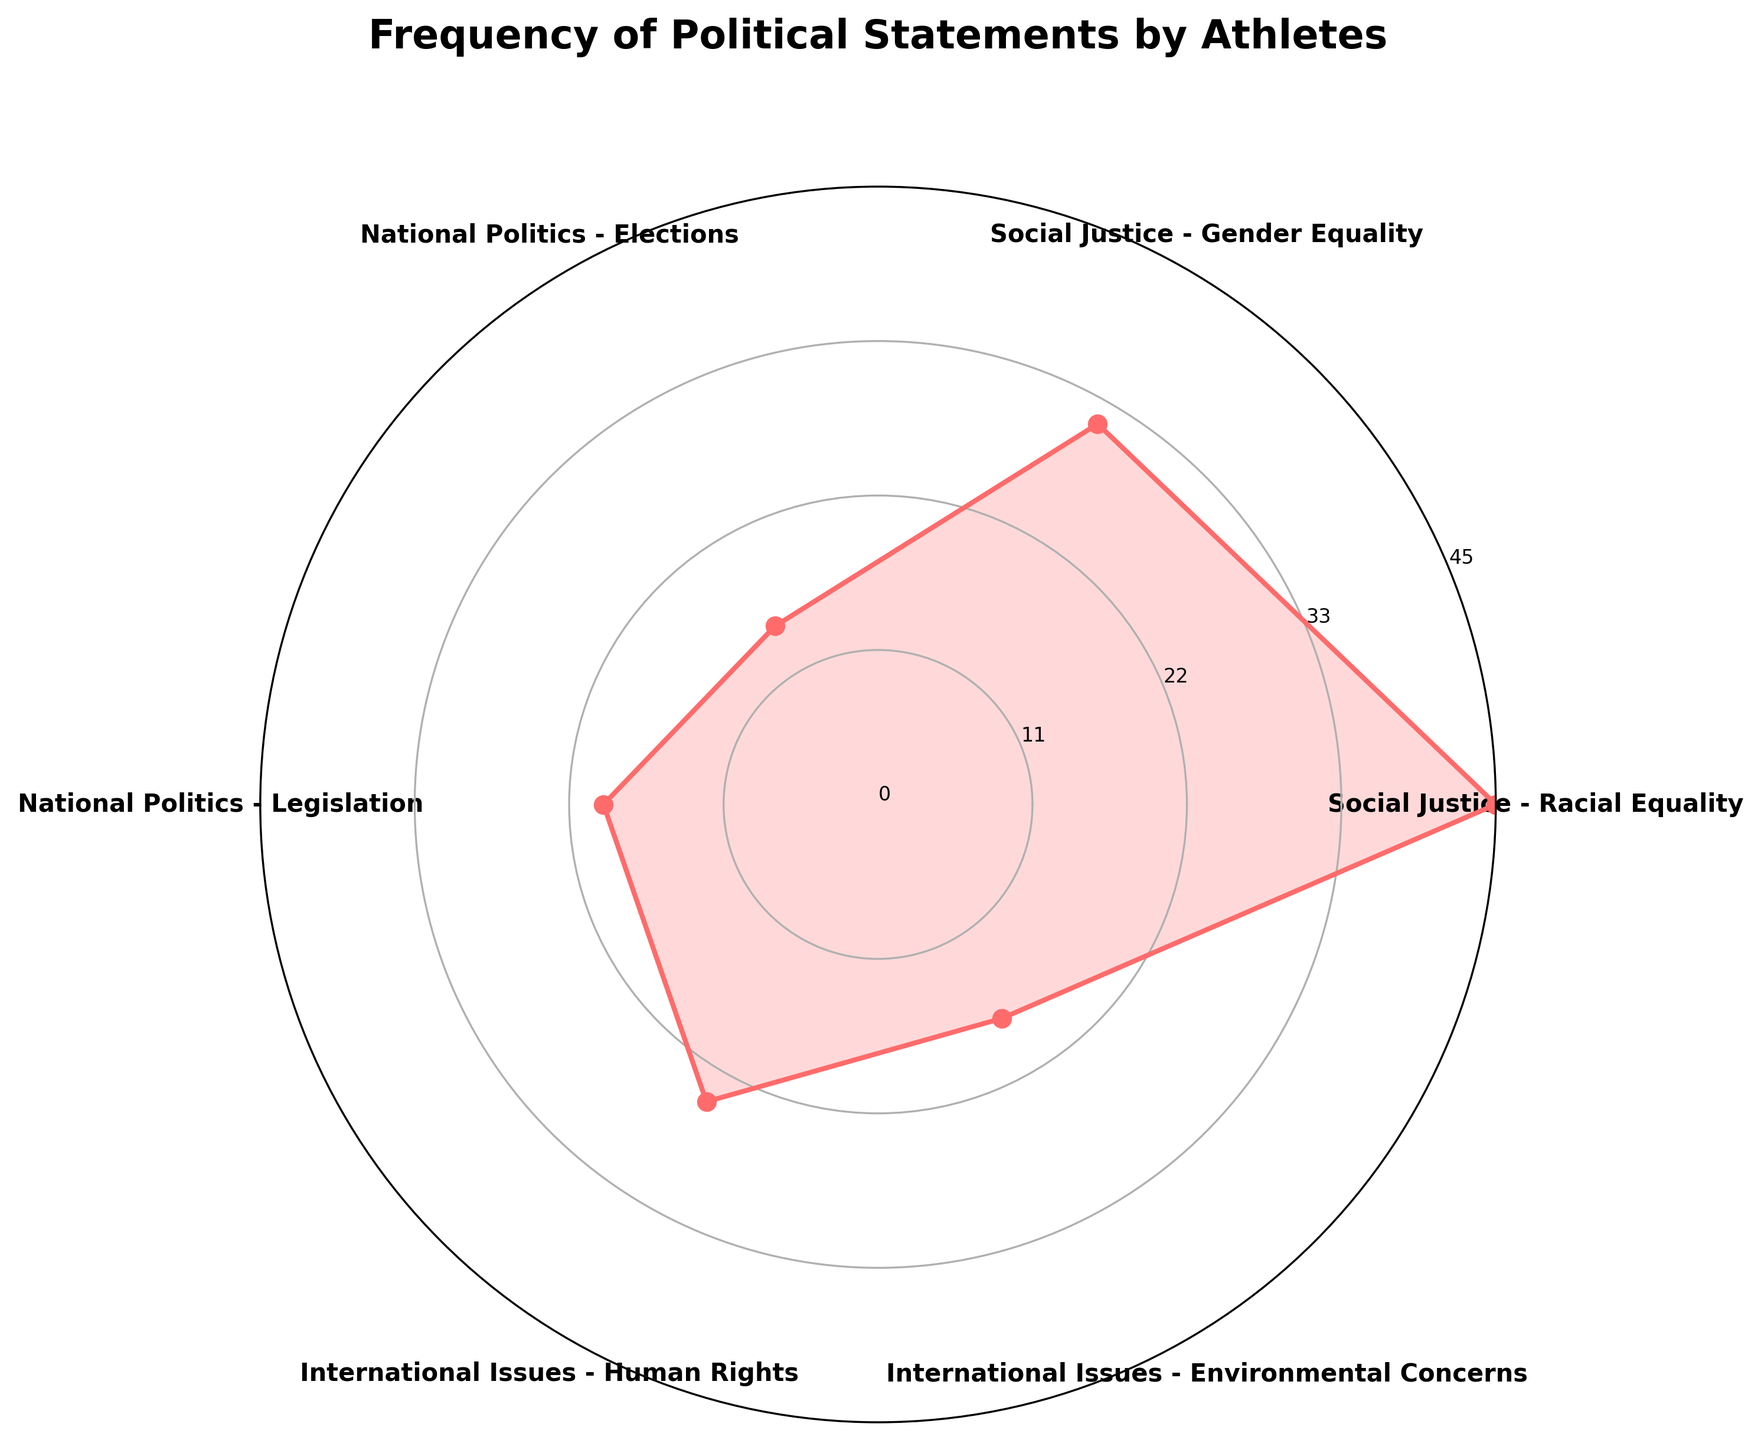How many different types of political statements are depicted in the chart? We can count the distinct segments in the rose chart. By observing each label, we determine there are six different types of political statements represented.
Answer: 6 Which category has the highest frequency of statements? The longest segment in the rose chart corresponds to the category with the highest frequency. From the labels, we see this is "Social Justice - Racial Equality" with a frequency of 45.
Answer: Social Justice - Racial Equality What is the combined frequency of statements related to national politics? We need to sum the frequencies for both categories under national politics. These are "National Politics - Elections" with 15 and "National Politics - Legislation" with 20. Therefore, the total is 15 + 20 = 35.
Answer: 35 How do the frequencies of "International Issues - Environmental Concerns" and "National Politics - Legislation" compare? We compare the lengths of the respective segments. "International Issues - Environmental Concerns" has a frequency of 18, while "National Politics - Legislation" has a frequency of 20. Therefore, National Politics - Legislation has a higher frequency.
Answer: National Politics - Legislation has a higher frequency What's the average frequency of statements for the "International Issues" categories? Sum the frequencies for the international issues categories ("International Issues - Human Rights" with 25 and "International Issues - Environmental Concerns" with 18) and divide by 2. (25 + 18) / 2 = 21.5
Answer: 21.5 Which category has the lowest frequency of statements? By finding the shortest segment on the rose chart, we see that "National Politics - Elections" has the lowest frequency at 15.
Answer: National Politics - Elections How many categories have a frequency higher than 20? By identifying segments that exceed the 20-mark on the radial axis, we measure that "Social Justice - Racial Equality" (45), "Social Justice - Gender Equality" (32), and "International Issues - Human Rights" (25) surpass this number. Hence, there are three categories.
Answer: 3 What's the total frequency of statements related to "Social Justice"? By summing the frequencies of "Social Justice - Racial Equality" (45) and "Social Justice - Gender Equality" (32), we get 45 + 32 = 77.
Answer: 77 